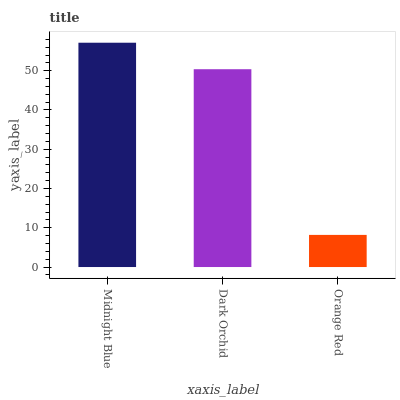Is Dark Orchid the minimum?
Answer yes or no. No. Is Dark Orchid the maximum?
Answer yes or no. No. Is Midnight Blue greater than Dark Orchid?
Answer yes or no. Yes. Is Dark Orchid less than Midnight Blue?
Answer yes or no. Yes. Is Dark Orchid greater than Midnight Blue?
Answer yes or no. No. Is Midnight Blue less than Dark Orchid?
Answer yes or no. No. Is Dark Orchid the high median?
Answer yes or no. Yes. Is Dark Orchid the low median?
Answer yes or no. Yes. Is Midnight Blue the high median?
Answer yes or no. No. Is Midnight Blue the low median?
Answer yes or no. No. 